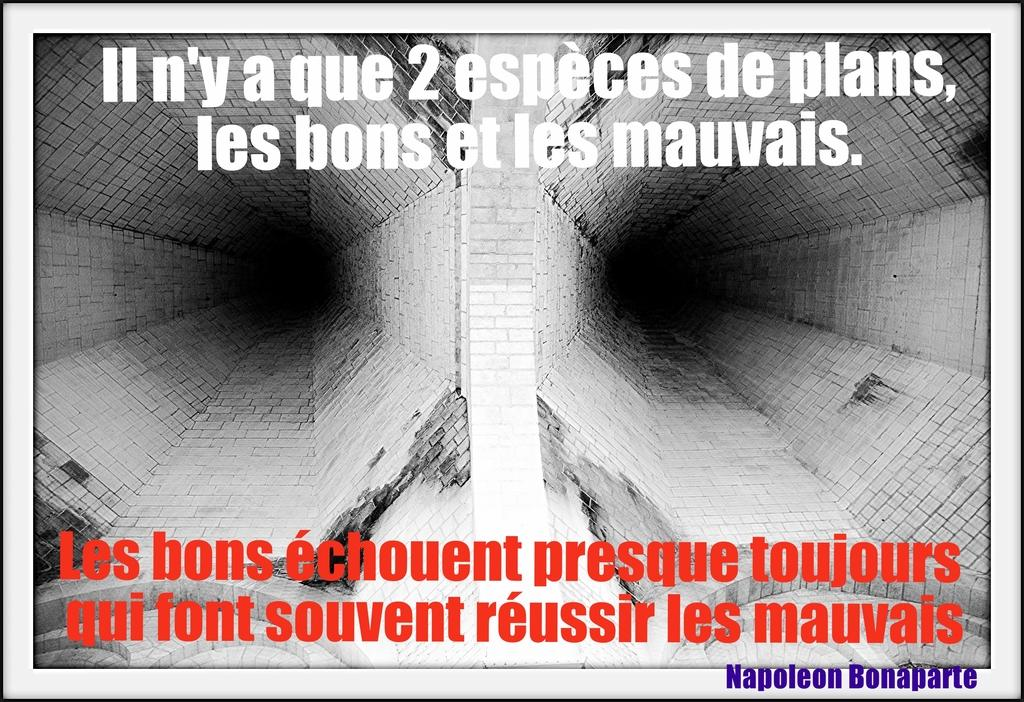<image>
Summarize the visual content of the image. Two tunnels made of brick and white text that says II n'y a que 2 especes de plans. 